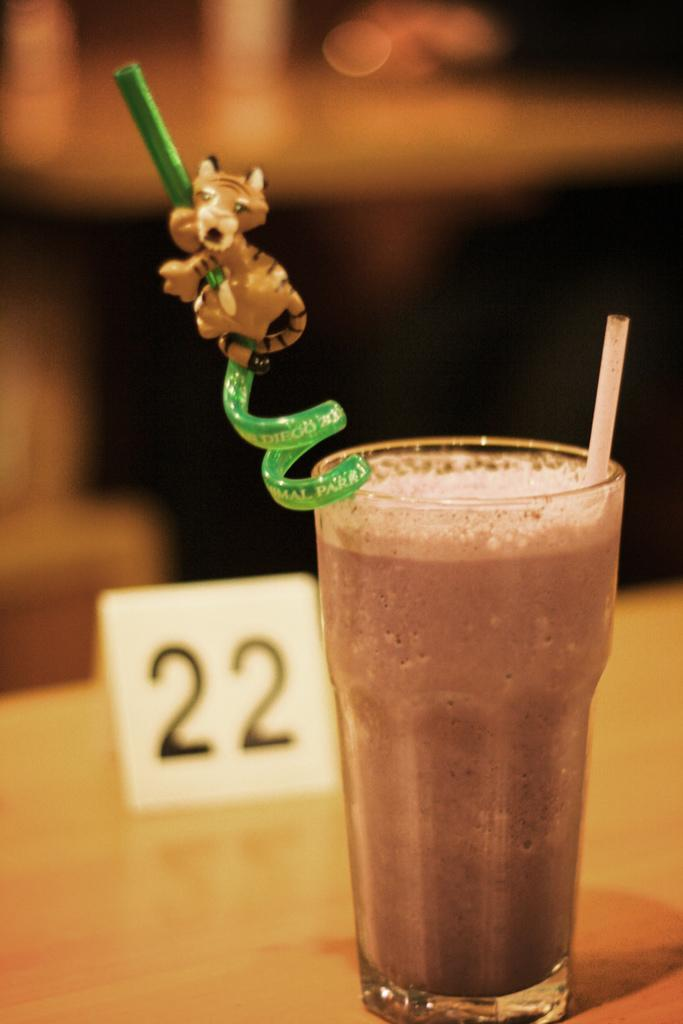What is in the glass that is visible in the image? There are straws in the glass in the image. What else can be seen on the table besides the glass? There is a board with numbers in the image. Where are the board and the glass located in the image? The board and the glass are placed on a table in the image. What type of jelly is being used to write on the board in the image? There is no jelly present in the image, and the board has numbers, not writing. Can you tell me how many shoes are visible in the image? There are no shoes present in the image. 